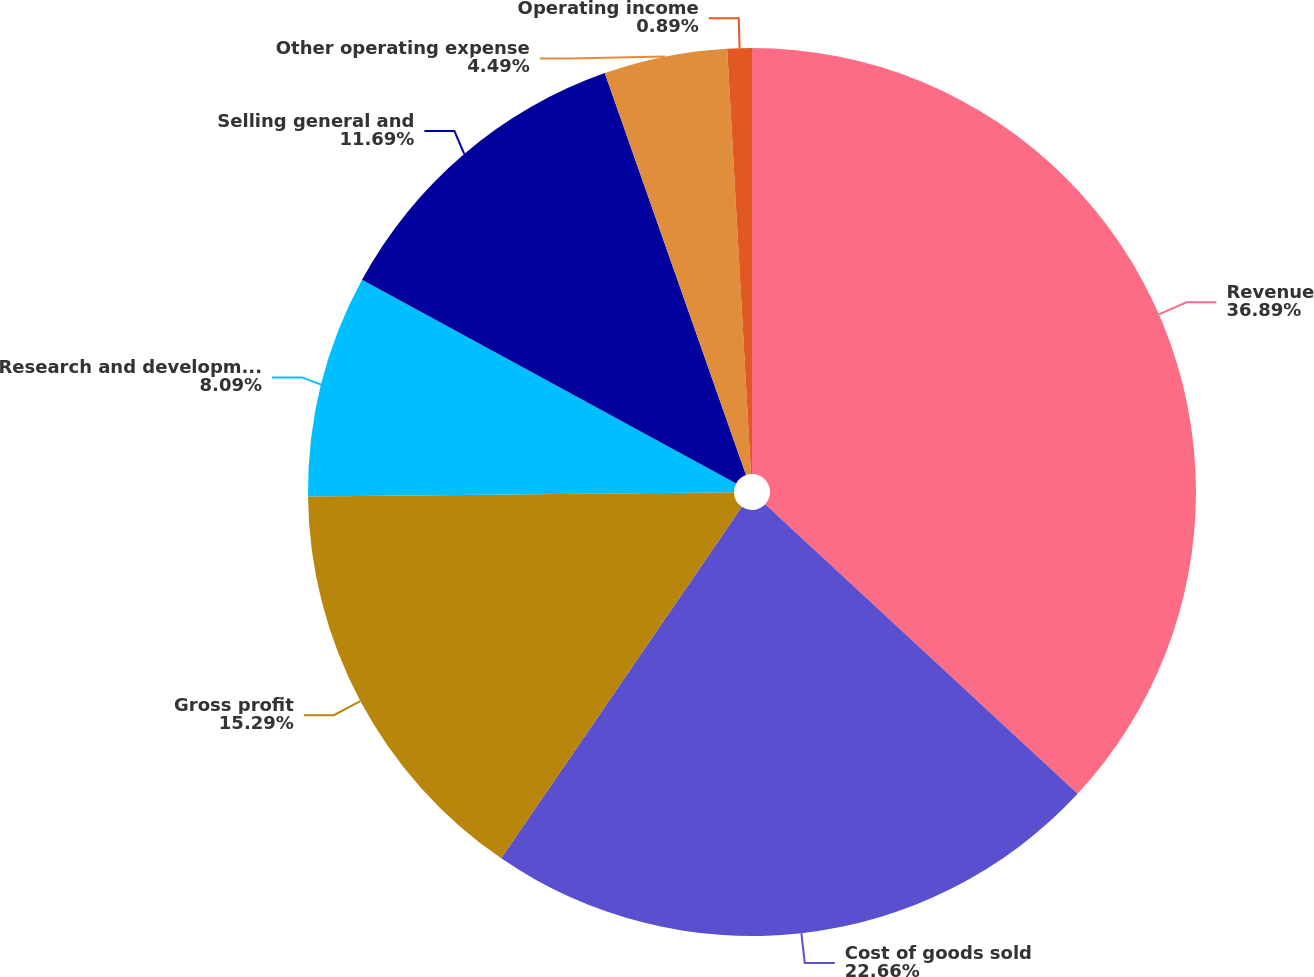Convert chart. <chart><loc_0><loc_0><loc_500><loc_500><pie_chart><fcel>Revenue<fcel>Cost of goods sold<fcel>Gross profit<fcel>Research and development<fcel>Selling general and<fcel>Other operating expense<fcel>Operating income<nl><fcel>36.9%<fcel>22.66%<fcel>15.29%<fcel>8.09%<fcel>11.69%<fcel>4.49%<fcel>0.89%<nl></chart> 